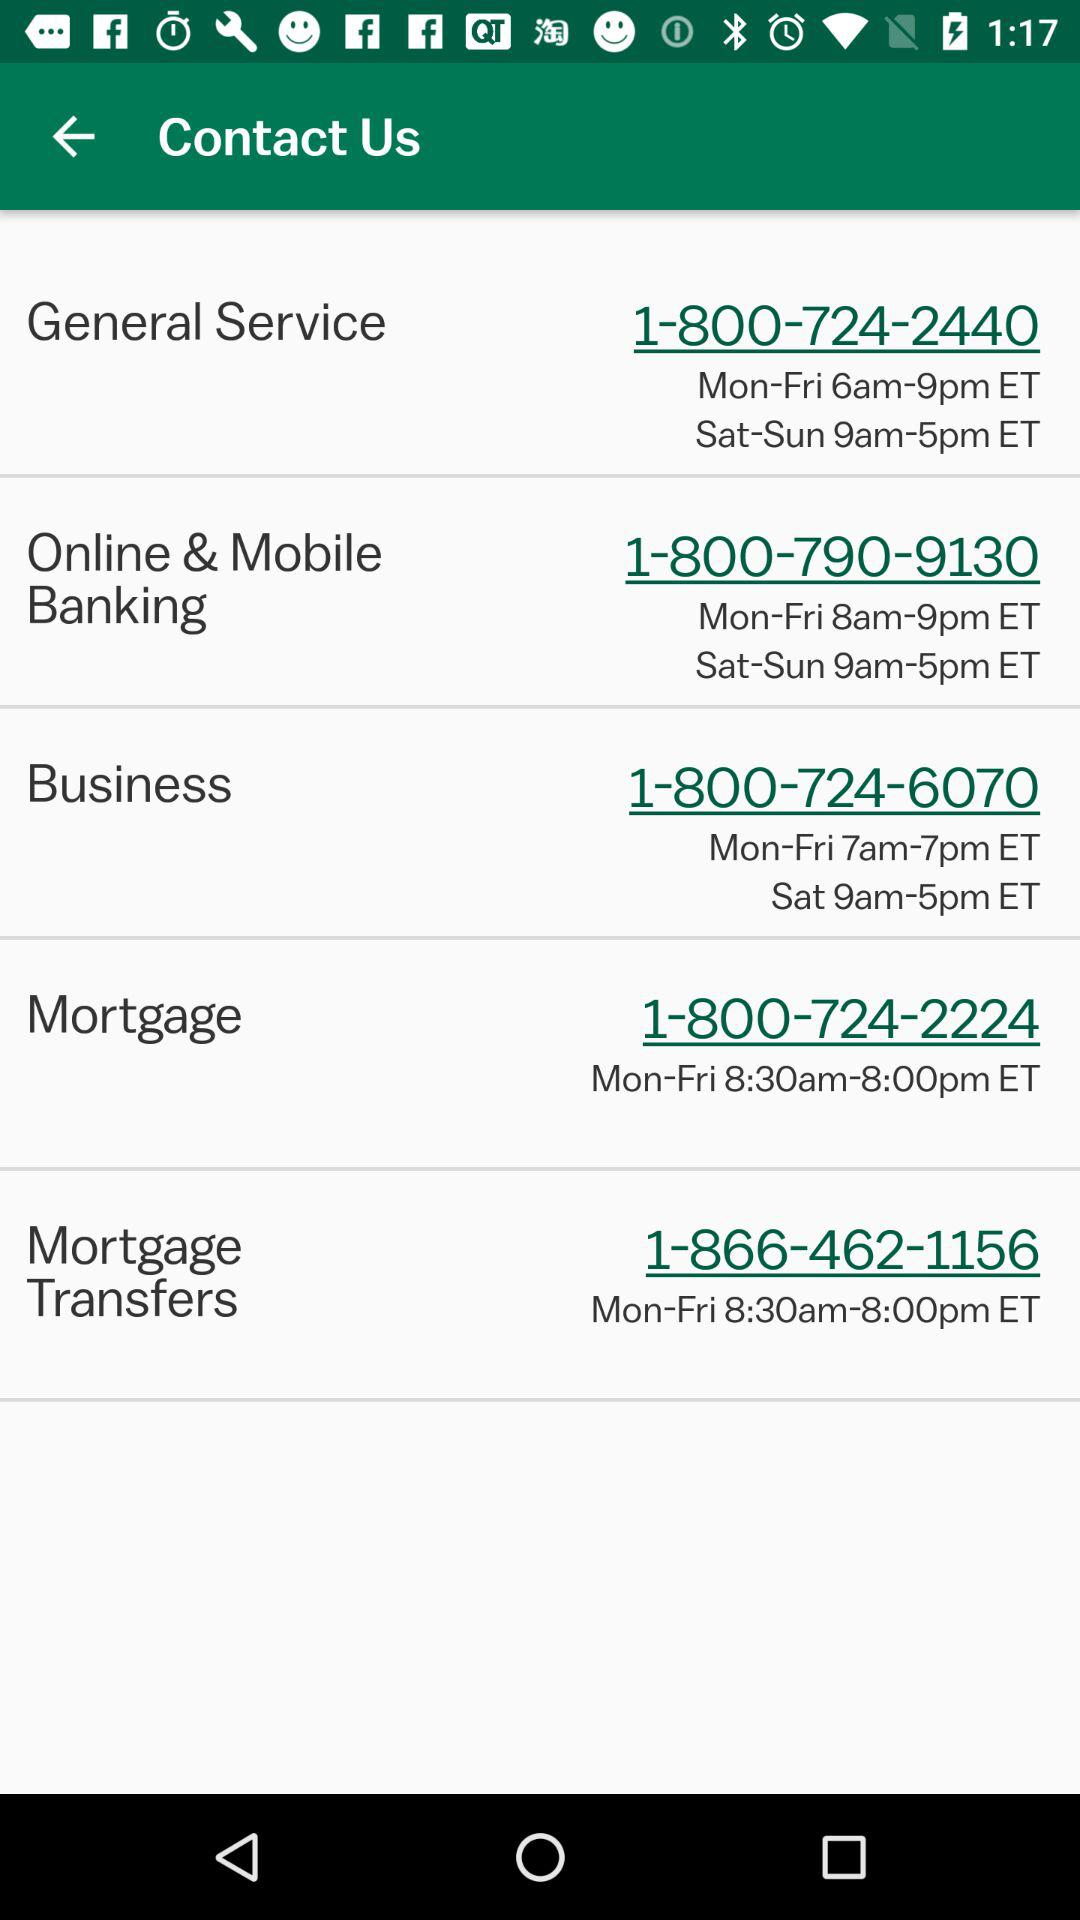Which is the mobile number for the "Mortgage Transfers"? The mobile number is 1-800-724-2224. 